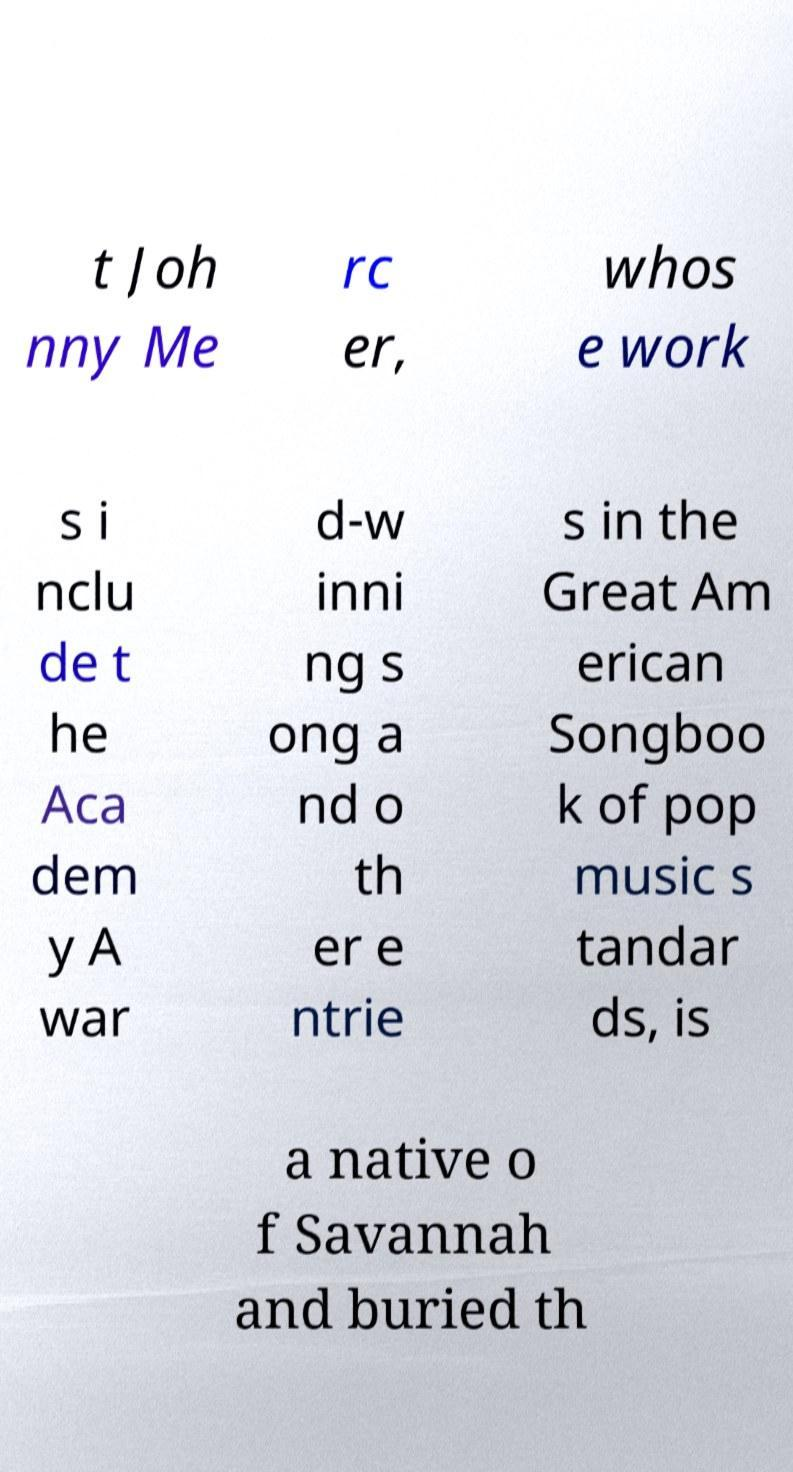Can you accurately transcribe the text from the provided image for me? t Joh nny Me rc er, whos e work s i nclu de t he Aca dem y A war d-w inni ng s ong a nd o th er e ntrie s in the Great Am erican Songboo k of pop music s tandar ds, is a native o f Savannah and buried th 